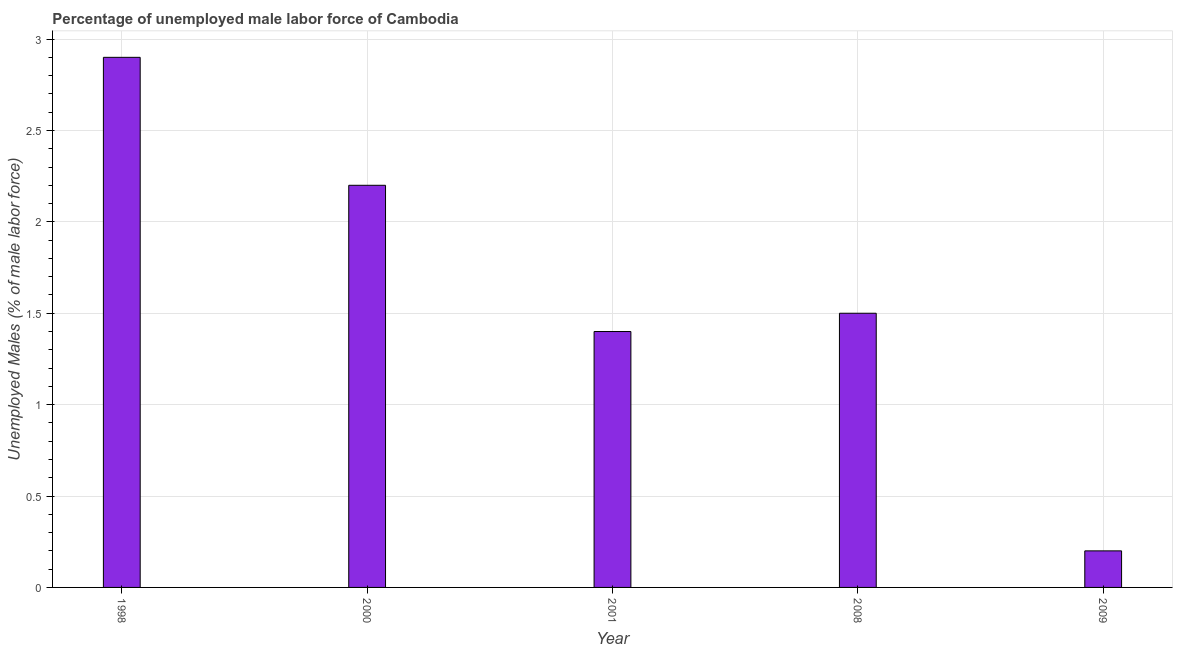Does the graph contain grids?
Give a very brief answer. Yes. What is the title of the graph?
Ensure brevity in your answer.  Percentage of unemployed male labor force of Cambodia. What is the label or title of the Y-axis?
Provide a succinct answer. Unemployed Males (% of male labor force). What is the total unemployed male labour force in 2001?
Your answer should be compact. 1.4. Across all years, what is the maximum total unemployed male labour force?
Give a very brief answer. 2.9. Across all years, what is the minimum total unemployed male labour force?
Make the answer very short. 0.2. In which year was the total unemployed male labour force maximum?
Keep it short and to the point. 1998. What is the sum of the total unemployed male labour force?
Ensure brevity in your answer.  8.2. What is the difference between the total unemployed male labour force in 1998 and 2000?
Provide a short and direct response. 0.7. What is the average total unemployed male labour force per year?
Make the answer very short. 1.64. Do a majority of the years between 1998 and 2000 (inclusive) have total unemployed male labour force greater than 2 %?
Offer a terse response. Yes. What is the ratio of the total unemployed male labour force in 2000 to that in 2008?
Provide a short and direct response. 1.47. What is the difference between the highest and the second highest total unemployed male labour force?
Your answer should be compact. 0.7. Is the sum of the total unemployed male labour force in 1998 and 2008 greater than the maximum total unemployed male labour force across all years?
Your response must be concise. Yes. What is the difference between the highest and the lowest total unemployed male labour force?
Provide a short and direct response. 2.7. How many years are there in the graph?
Your response must be concise. 5. What is the difference between two consecutive major ticks on the Y-axis?
Offer a terse response. 0.5. Are the values on the major ticks of Y-axis written in scientific E-notation?
Your response must be concise. No. What is the Unemployed Males (% of male labor force) of 1998?
Keep it short and to the point. 2.9. What is the Unemployed Males (% of male labor force) in 2000?
Make the answer very short. 2.2. What is the Unemployed Males (% of male labor force) of 2001?
Offer a very short reply. 1.4. What is the Unemployed Males (% of male labor force) of 2008?
Your answer should be very brief. 1.5. What is the Unemployed Males (% of male labor force) in 2009?
Ensure brevity in your answer.  0.2. What is the difference between the Unemployed Males (% of male labor force) in 1998 and 2000?
Offer a terse response. 0.7. What is the difference between the Unemployed Males (% of male labor force) in 1998 and 2001?
Keep it short and to the point. 1.5. What is the difference between the Unemployed Males (% of male labor force) in 1998 and 2009?
Ensure brevity in your answer.  2.7. What is the difference between the Unemployed Males (% of male labor force) in 2000 and 2001?
Make the answer very short. 0.8. What is the difference between the Unemployed Males (% of male labor force) in 2000 and 2008?
Offer a very short reply. 0.7. What is the difference between the Unemployed Males (% of male labor force) in 2001 and 2009?
Ensure brevity in your answer.  1.2. What is the ratio of the Unemployed Males (% of male labor force) in 1998 to that in 2000?
Ensure brevity in your answer.  1.32. What is the ratio of the Unemployed Males (% of male labor force) in 1998 to that in 2001?
Ensure brevity in your answer.  2.07. What is the ratio of the Unemployed Males (% of male labor force) in 1998 to that in 2008?
Give a very brief answer. 1.93. What is the ratio of the Unemployed Males (% of male labor force) in 1998 to that in 2009?
Provide a short and direct response. 14.5. What is the ratio of the Unemployed Males (% of male labor force) in 2000 to that in 2001?
Offer a terse response. 1.57. What is the ratio of the Unemployed Males (% of male labor force) in 2000 to that in 2008?
Offer a very short reply. 1.47. What is the ratio of the Unemployed Males (% of male labor force) in 2001 to that in 2008?
Your answer should be very brief. 0.93. 